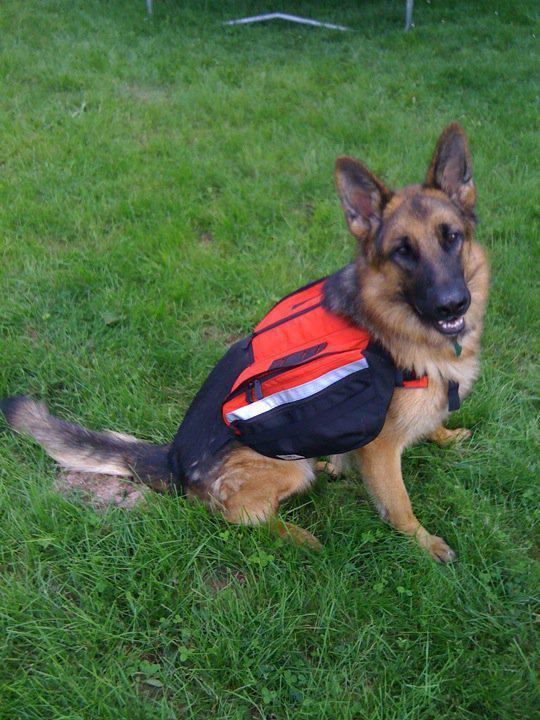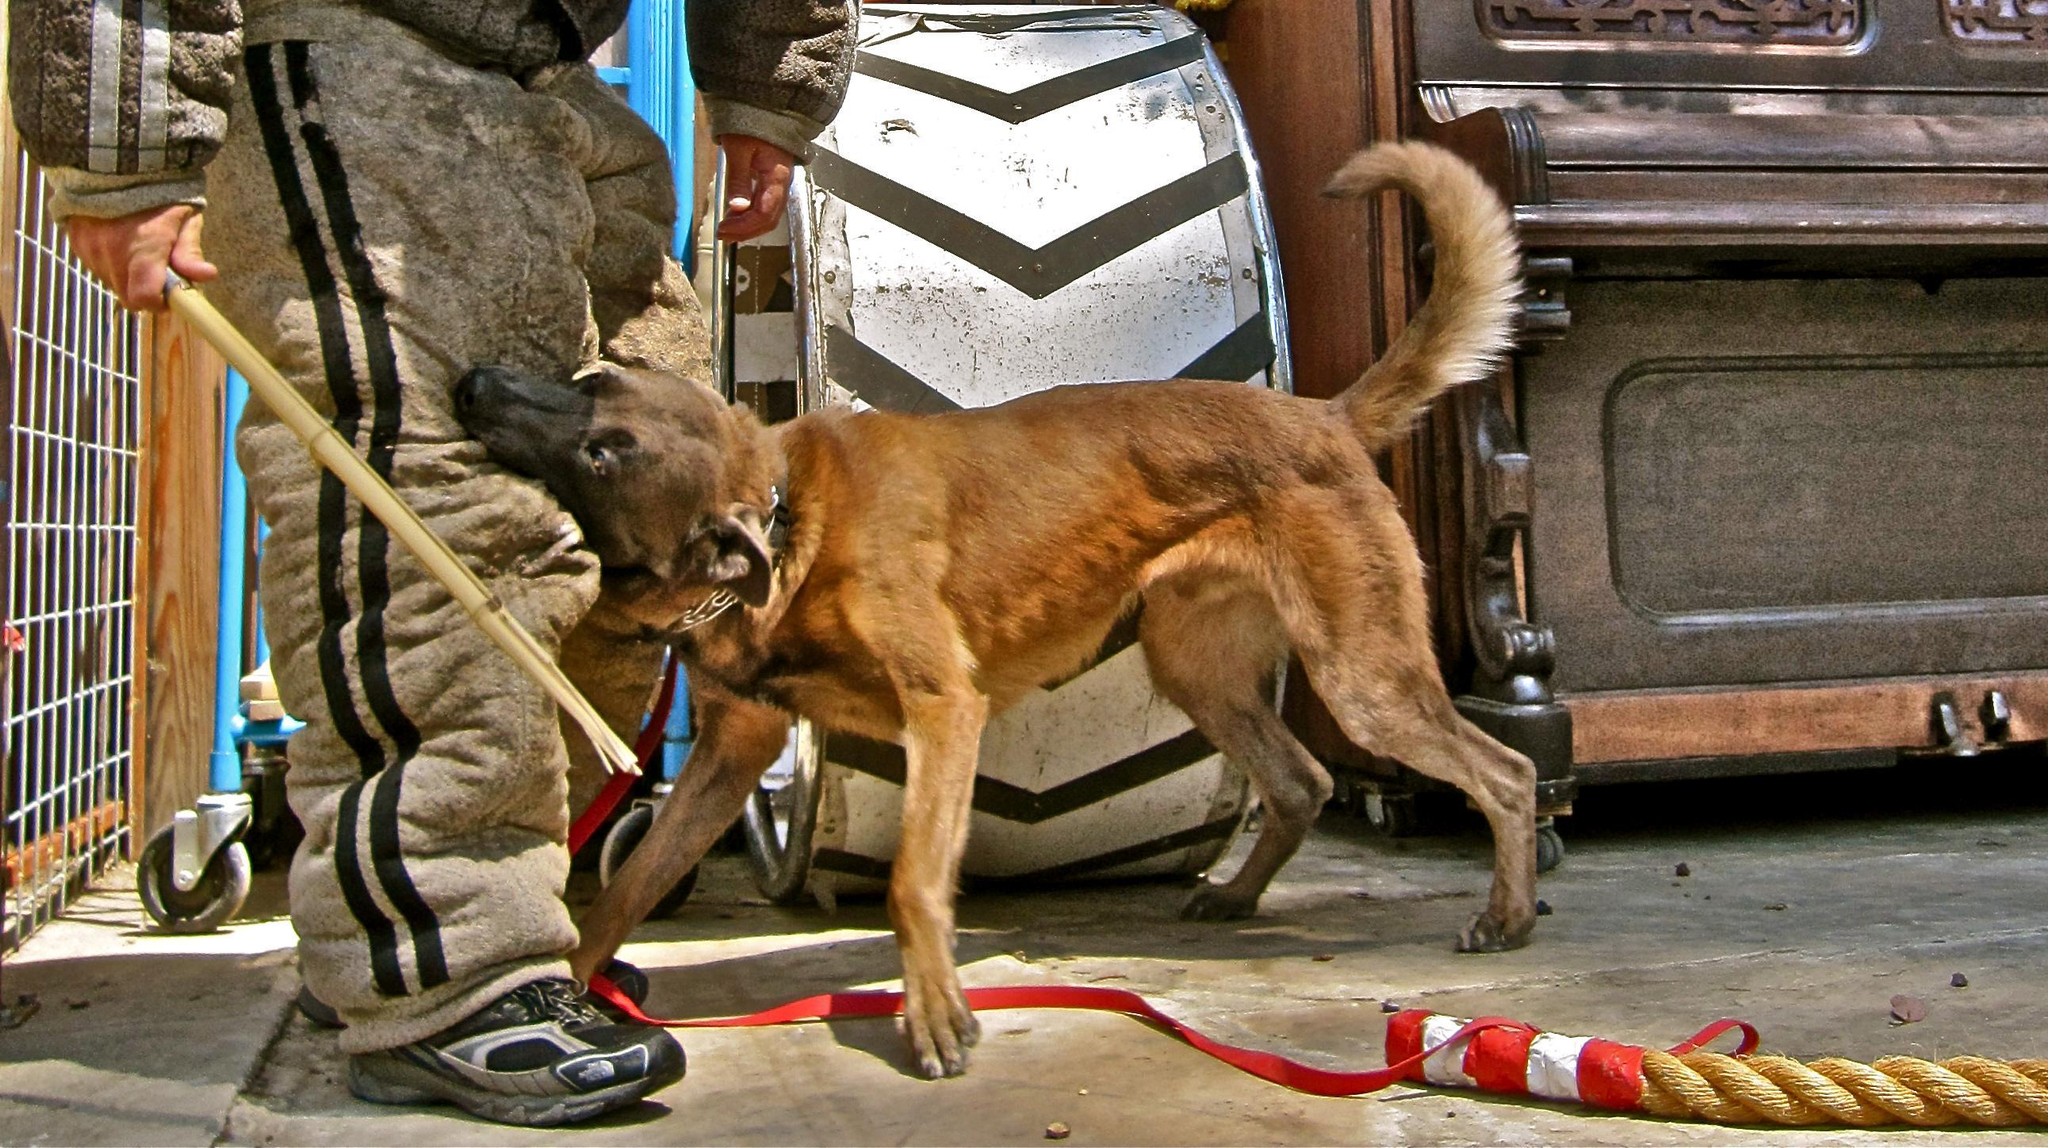The first image is the image on the left, the second image is the image on the right. Analyze the images presented: Is the assertion "One image shows a german shepherd in a harness vest sitting upright, and the othe image shows a man in padded pants holding a stick near a dog." valid? Answer yes or no. Yes. The first image is the image on the left, the second image is the image on the right. Analyze the images presented: Is the assertion "There is a single human in the pair of images." valid? Answer yes or no. Yes. 